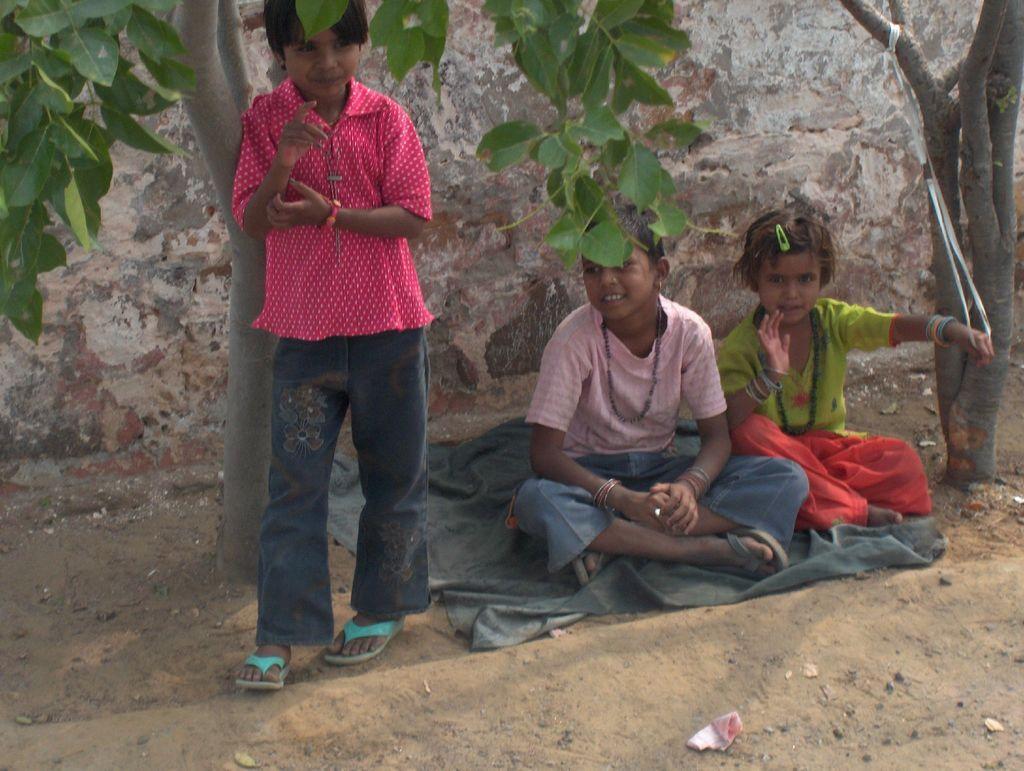Describe this image in one or two sentences. In this image, there are a few people. Among them, some people are sitting on a cloth. We can see the ground with an object. We can see some trees and the wall. 